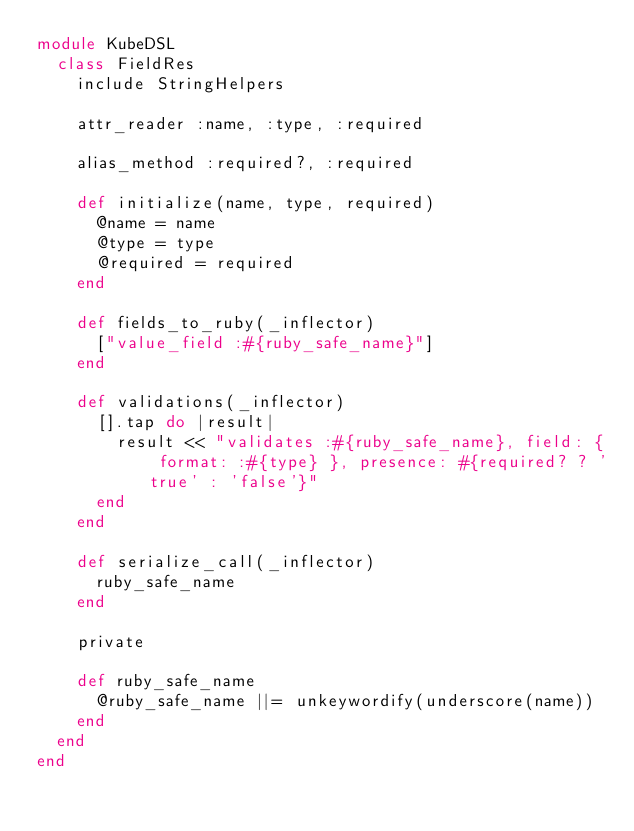Convert code to text. <code><loc_0><loc_0><loc_500><loc_500><_Ruby_>module KubeDSL
  class FieldRes
    include StringHelpers

    attr_reader :name, :type, :required

    alias_method :required?, :required

    def initialize(name, type, required)
      @name = name
      @type = type
      @required = required
    end

    def fields_to_ruby(_inflector)
      ["value_field :#{ruby_safe_name}"]
    end

    def validations(_inflector)
      [].tap do |result|
        result << "validates :#{ruby_safe_name}, field: { format: :#{type} }, presence: #{required? ? 'true' : 'false'}"
      end
    end

    def serialize_call(_inflector)
      ruby_safe_name
    end

    private

    def ruby_safe_name
      @ruby_safe_name ||= unkeywordify(underscore(name))
    end
  end
end
</code> 